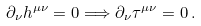<formula> <loc_0><loc_0><loc_500><loc_500>\partial _ { \nu } h ^ { \mu \nu } = 0 \Longrightarrow \partial _ { \nu } \tau ^ { \mu \nu } = 0 \, .</formula> 